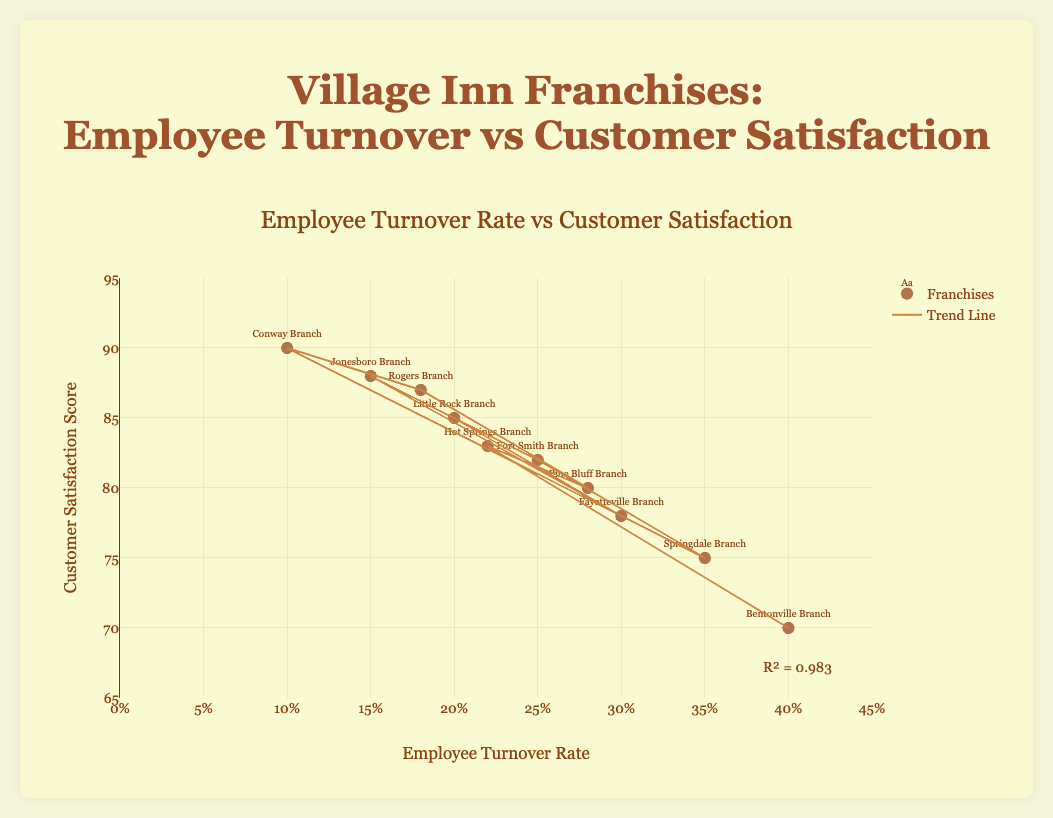What is the title of the scatter plot? The title appears at the top of the plot, highlighting the main topic being visualized.
Answer: Employee Turnover Rate vs Customer Satisfaction How many franchises are represented in the scatter plot? Each franchise is represented by a unique data point, and by counting these, we get the total number of franchises. There are 10 data points with labels.
Answer: 10 Which franchise has the highest customer satisfaction score? Identify the franchise name associated with the highest position on the y-axis, which represents customer satisfaction score. The highest y-value is 90.
Answer: Conway Branch What is the trend of customer satisfaction as employee turnover rate increases? The trend is represented by the trendline in the scatter plot. Observe if it slopes upward or downward to determine if customer satisfaction increases or decreases as employee turnover rate changes.
Answer: Decreases What is the employee turnover rate for the Rogers Branch? Locate the data point labeled "Rogers Branch" and check its position on the x-axis which represents the employee turnover rate.
Answer: 0.18 Which branch has the lowest employee turnover rate, and what is the corresponding customer satisfaction score? Find the data point with the lowest x-value and identify both the branch and its corresponding y-value.
Answer: Conway Branch, 90 What is the R² value for the trendline? The R² value is usually displayed near the plot itself, indicating the strength of the correlation between the two variables.
Answer: 0.588 Compare the customer satisfaction scores between Fayetteville Branch and Bentonville Branch. Which one is lower? Locate both branches and compare their y-axis values (customer satisfaction scores). Fayetteville is 78, Bentonville is 70.
Answer: Bentonville Branch Calculate the average employee turnover rate across all franchises. Sum all the employee turnover rates and divide by the number of franchises. (0.2 + 0.3 + 0.15 + 0.25 + 0.35 + 0.1 + 0.18 + 0.28 + 0.22 + 0.4) / 10 = 0.243
Answer: 0.243 Which branch has the closest customer satisfaction score to the trendline's value at a 0.2 employee turnover rate? Find the trendline value at 0.2 on the x-axis, then find the branch with the y-value closest to this trendline score. Trendline value approximately 85 at 0.2. Little Rock Branch has a satisfaction score of 85.
Answer: Little Rock Branch 